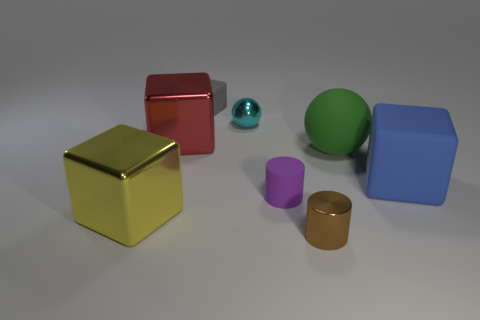Subtract all tiny blocks. How many blocks are left? 3 Subtract all cyan balls. How many balls are left? 1 Subtract all spheres. How many objects are left? 6 Add 2 big purple matte cubes. How many objects exist? 10 Add 1 large rubber blocks. How many large rubber blocks exist? 2 Subtract 1 gray blocks. How many objects are left? 7 Subtract 2 cubes. How many cubes are left? 2 Subtract all red spheres. Subtract all brown cylinders. How many spheres are left? 2 Subtract all small blue shiny objects. Subtract all purple matte cylinders. How many objects are left? 7 Add 3 big yellow metal blocks. How many big yellow metal blocks are left? 4 